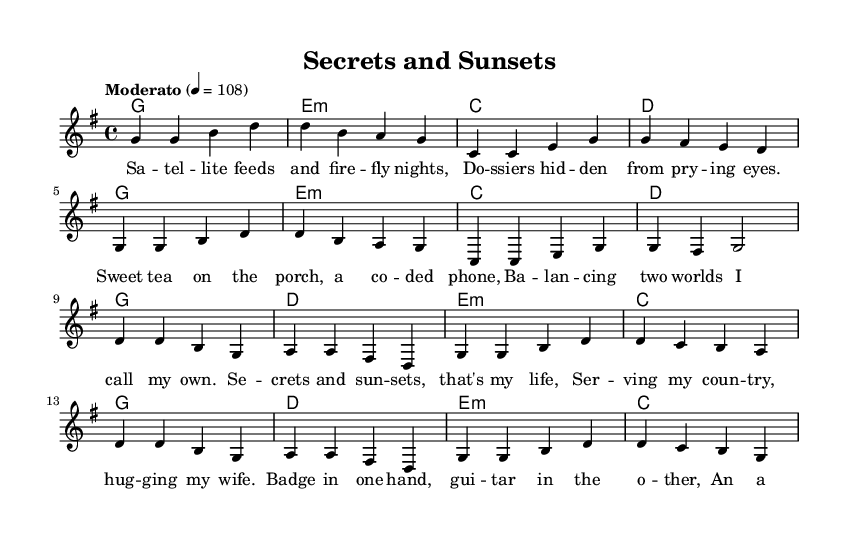What is the key signature of this music? The key signature is G major, which has one sharp (F#). This can be identified from the key signature indicated at the beginning of the sheet music.
Answer: G major What is the time signature of this music? The time signature is 4/4, meaning there are four beats in a measure and the quarter note gets one beat. This is explicitly stated in the sheet music notation.
Answer: 4/4 What is the tempo marking for this piece? The tempo marking is "Moderato" set at a speed of 108 beats per minute. This is shown above the staff in the tempo section.
Answer: Moderato 108 How many measures are in the verse section? The verse section consists of 8 measures as counted through the notation provided under melody. Each line of melody contains 4 measures, and there are 2 lines in the verse section.
Answer: 8 measures What are the two worlds mentioned in the lyrics? The two worlds refer to the dual existence as an intelligence agent and a family person, serving the country while maintaining personal life. This can be inferred from the thematic content of the lyrics, specifically from the line discussing balancing two worlds.
Answer: Intelligence and personal life What is the repeated musical phrase in the chorus? The repeated musical phrase in the chorus is primarily structured around the notes d b g and a a fis d, seen throughout the chorus section. This repetition is typical of country music's lyrical structure.
Answer: d b g and a a fis d 